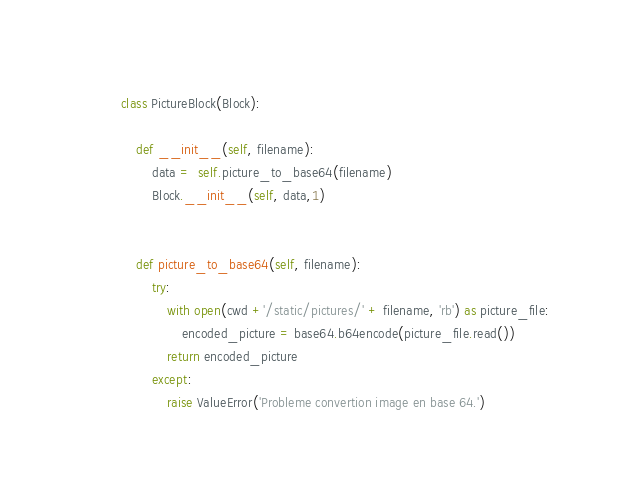Convert code to text. <code><loc_0><loc_0><loc_500><loc_500><_Python_>

class PictureBlock(Block):

    def __init__(self, filename):
        data =  self.picture_to_base64(filename)
        Block.__init__(self, data,1)
        
    
    def picture_to_base64(self, filename):
        try:
            with open(cwd +'/static/pictures/' + filename, 'rb') as picture_file:
                encoded_picture = base64.b64encode(picture_file.read())
            return encoded_picture
        except:
            raise ValueError('Probleme convertion image en base 64.')</code> 